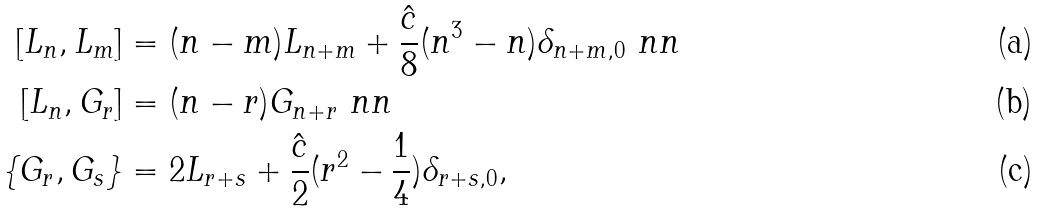<formula> <loc_0><loc_0><loc_500><loc_500>[ L _ { n } , L _ { m } ] & = ( n - m ) L _ { n + m } + \frac { \hat { c } } { 8 } ( n ^ { 3 } - n ) \delta _ { n + m , 0 } \ n n \\ [ L _ { n } , G _ { r } ] & = ( n - r ) G _ { n + r } \ n n \\ \{ G _ { r } , G _ { s } \} & = 2 L _ { r + s } + \frac { \hat { c } } { 2 } ( r ^ { 2 } - \frac { 1 } { 4 } ) \delta _ { r + s , 0 } ,</formula> 